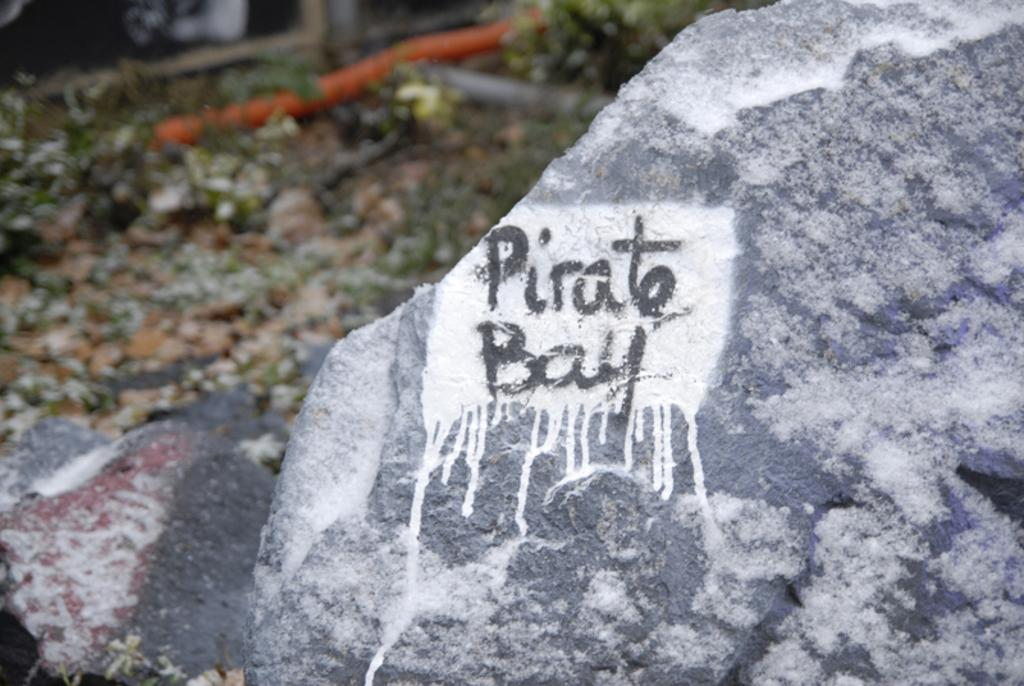What is written on in the image? There is text written on a stone in the image. What can be seen in the background of the image? In the background, there are small stones, a pipe, and small plants. What type of lock is used to secure the structure in the image? There is no structure or lock present in the image; it features text written on a stone and elements in the background. 